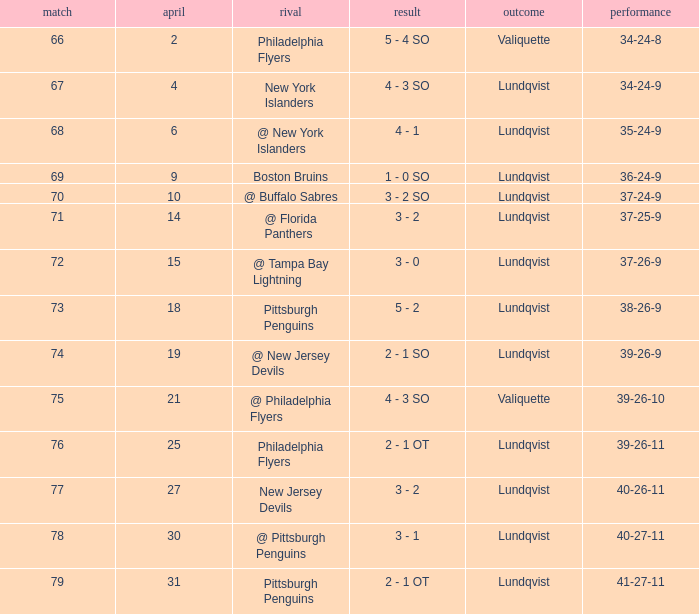Which score's game was less than 69 when the march was bigger than 2 and the opponents were the New York Islanders? 4 - 3 SO. 